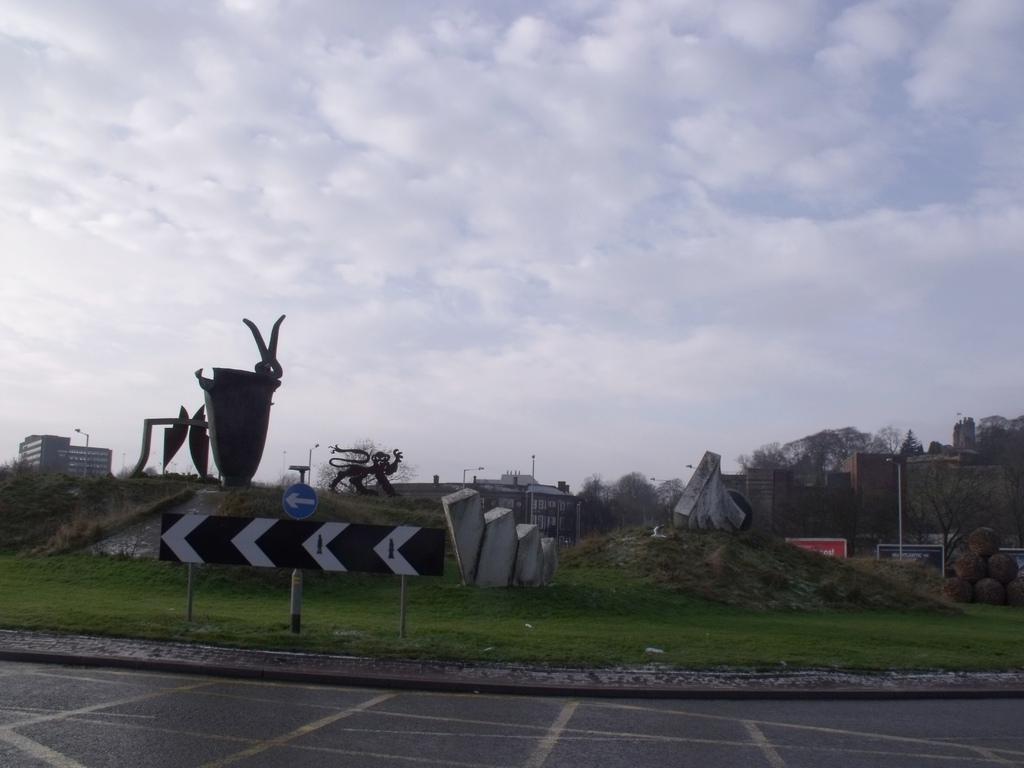Please provide a concise description of this image. At the bottom of the image there is a road. At the center of the image there are statues, rock structures, grass, trees and buildings. In the background there is a sky. 